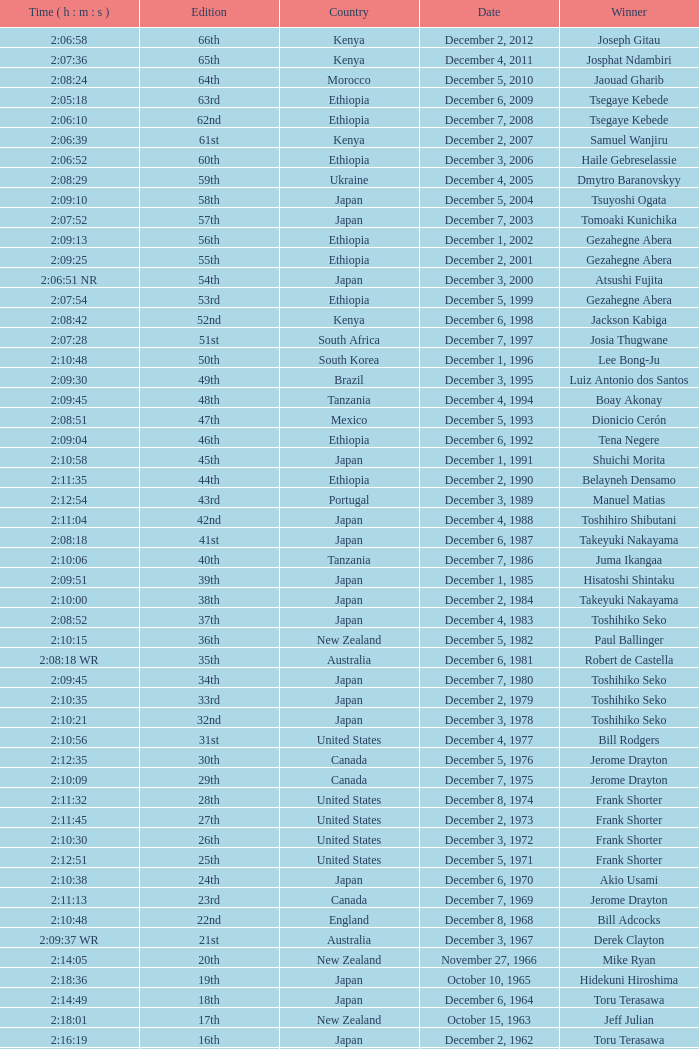What was the nationality of the winner of the 42nd Edition? Japan. Give me the full table as a dictionary. {'header': ['Time ( h : m : s )', 'Edition', 'Country', 'Date', 'Winner'], 'rows': [['2:06:58', '66th', 'Kenya', 'December 2, 2012', 'Joseph Gitau'], ['2:07:36', '65th', 'Kenya', 'December 4, 2011', 'Josphat Ndambiri'], ['2:08:24', '64th', 'Morocco', 'December 5, 2010', 'Jaouad Gharib'], ['2:05:18', '63rd', 'Ethiopia', 'December 6, 2009', 'Tsegaye Kebede'], ['2:06:10', '62nd', 'Ethiopia', 'December 7, 2008', 'Tsegaye Kebede'], ['2:06:39', '61st', 'Kenya', 'December 2, 2007', 'Samuel Wanjiru'], ['2:06:52', '60th', 'Ethiopia', 'December 3, 2006', 'Haile Gebreselassie'], ['2:08:29', '59th', 'Ukraine', 'December 4, 2005', 'Dmytro Baranovskyy'], ['2:09:10', '58th', 'Japan', 'December 5, 2004', 'Tsuyoshi Ogata'], ['2:07:52', '57th', 'Japan', 'December 7, 2003', 'Tomoaki Kunichika'], ['2:09:13', '56th', 'Ethiopia', 'December 1, 2002', 'Gezahegne Abera'], ['2:09:25', '55th', 'Ethiopia', 'December 2, 2001', 'Gezahegne Abera'], ['2:06:51 NR', '54th', 'Japan', 'December 3, 2000', 'Atsushi Fujita'], ['2:07:54', '53rd', 'Ethiopia', 'December 5, 1999', 'Gezahegne Abera'], ['2:08:42', '52nd', 'Kenya', 'December 6, 1998', 'Jackson Kabiga'], ['2:07:28', '51st', 'South Africa', 'December 7, 1997', 'Josia Thugwane'], ['2:10:48', '50th', 'South Korea', 'December 1, 1996', 'Lee Bong-Ju'], ['2:09:30', '49th', 'Brazil', 'December 3, 1995', 'Luiz Antonio dos Santos'], ['2:09:45', '48th', 'Tanzania', 'December 4, 1994', 'Boay Akonay'], ['2:08:51', '47th', 'Mexico', 'December 5, 1993', 'Dionicio Cerón'], ['2:09:04', '46th', 'Ethiopia', 'December 6, 1992', 'Tena Negere'], ['2:10:58', '45th', 'Japan', 'December 1, 1991', 'Shuichi Morita'], ['2:11:35', '44th', 'Ethiopia', 'December 2, 1990', 'Belayneh Densamo'], ['2:12:54', '43rd', 'Portugal', 'December 3, 1989', 'Manuel Matias'], ['2:11:04', '42nd', 'Japan', 'December 4, 1988', 'Toshihiro Shibutani'], ['2:08:18', '41st', 'Japan', 'December 6, 1987', 'Takeyuki Nakayama'], ['2:10:06', '40th', 'Tanzania', 'December 7, 1986', 'Juma Ikangaa'], ['2:09:51', '39th', 'Japan', 'December 1, 1985', 'Hisatoshi Shintaku'], ['2:10:00', '38th', 'Japan', 'December 2, 1984', 'Takeyuki Nakayama'], ['2:08:52', '37th', 'Japan', 'December 4, 1983', 'Toshihiko Seko'], ['2:10:15', '36th', 'New Zealand', 'December 5, 1982', 'Paul Ballinger'], ['2:08:18 WR', '35th', 'Australia', 'December 6, 1981', 'Robert de Castella'], ['2:09:45', '34th', 'Japan', 'December 7, 1980', 'Toshihiko Seko'], ['2:10:35', '33rd', 'Japan', 'December 2, 1979', 'Toshihiko Seko'], ['2:10:21', '32nd', 'Japan', 'December 3, 1978', 'Toshihiko Seko'], ['2:10:56', '31st', 'United States', 'December 4, 1977', 'Bill Rodgers'], ['2:12:35', '30th', 'Canada', 'December 5, 1976', 'Jerome Drayton'], ['2:10:09', '29th', 'Canada', 'December 7, 1975', 'Jerome Drayton'], ['2:11:32', '28th', 'United States', 'December 8, 1974', 'Frank Shorter'], ['2:11:45', '27th', 'United States', 'December 2, 1973', 'Frank Shorter'], ['2:10:30', '26th', 'United States', 'December 3, 1972', 'Frank Shorter'], ['2:12:51', '25th', 'United States', 'December 5, 1971', 'Frank Shorter'], ['2:10:38', '24th', 'Japan', 'December 6, 1970', 'Akio Usami'], ['2:11:13', '23rd', 'Canada', 'December 7, 1969', 'Jerome Drayton'], ['2:10:48', '22nd', 'England', 'December 8, 1968', 'Bill Adcocks'], ['2:09:37 WR', '21st', 'Australia', 'December 3, 1967', 'Derek Clayton'], ['2:14:05', '20th', 'New Zealand', 'November 27, 1966', 'Mike Ryan'], ['2:18:36', '19th', 'Japan', 'October 10, 1965', 'Hidekuni Hiroshima'], ['2:14:49', '18th', 'Japan', 'December 6, 1964', 'Toru Terasawa'], ['2:18:01', '17th', 'New Zealand', 'October 15, 1963', 'Jeff Julian'], ['2:16:19', '16th', 'Japan', 'December 2, 1962', 'Toru Terasawa'], ['2:22:05', '15th', 'Czech Republic', 'December 3, 1961', 'Pavel Kantorek'], ['2:19:04', '14th', 'New Zealand', 'December 4, 1960', 'Barry Magee'], ['2:29:34', '13th', 'Japan', 'November 8, 1959', 'Kurao Hiroshima'], ['2:24:01', '12th', 'Japan', 'December 7, 1958', 'Nobuyoshi Sadanaga'], ['2:21:40', '11th', 'Japan', 'December 1, 1957', 'Kurao Hiroshima'], ['2:25:15', '10th', 'Japan', 'December 9, 1956', 'Keizo Yamada'], ['2:23:16', '9th', 'Finland', 'December 11, 1955', 'Veikko Karvonen'], ['2:24:55', '8th', 'Argentina', 'December 5, 1954', 'Reinaldo Gorno'], ['2:27:26', '7th', 'Japan', 'December 6, 1953', 'Hideo Hamamura'], ['2:27:59', '6th', 'Japan', 'December 7, 1952', 'Katsuo Nishida'], ['2:30:13', '5th', 'Japan', 'December 9, 1951', 'Hiromi Haigo'], ['2:30:47', '4th', 'Japan', 'December 10, 1950', 'Shunji Koyanagi'], ['2:40:26', '3rd', 'Japan', 'December 4, 1949', 'Shinzo Koga'], ['2:37:25', '2nd', 'Japan', 'December 5, 1948', 'Saburo Yamada'], ['2:45:45', '1st', 'Japan', 'December 7, 1947', 'Toshikazu Wada']]} 